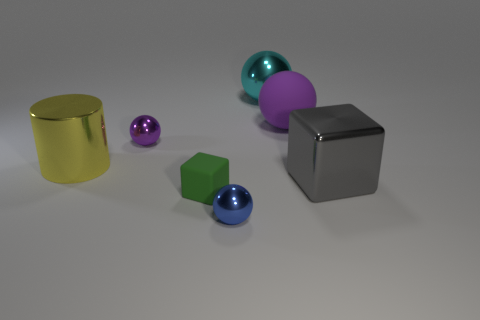Add 2 red things. How many objects exist? 9 Subtract all blocks. How many objects are left? 5 Add 2 rubber blocks. How many rubber blocks are left? 3 Add 2 big red matte cylinders. How many big red matte cylinders exist? 2 Subtract 1 gray blocks. How many objects are left? 6 Subtract all green matte cubes. Subtract all big metal things. How many objects are left? 3 